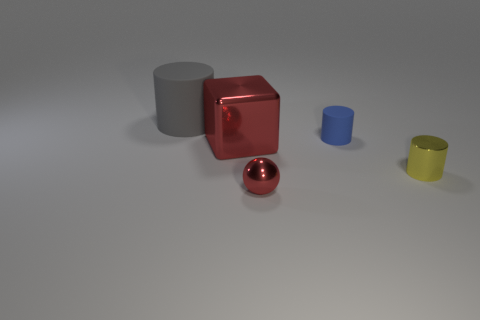What number of big blocks are in front of the cylinder behind the blue cylinder?
Offer a terse response. 1. There is a rubber object in front of the rubber thing that is left of the blue rubber cylinder; what color is it?
Your answer should be very brief. Blue. There is a thing that is both behind the large metal object and to the right of the red metallic block; what is it made of?
Make the answer very short. Rubber. Is there another rubber object of the same shape as the gray thing?
Provide a short and direct response. Yes. There is a large object in front of the blue object; does it have the same shape as the gray rubber object?
Provide a short and direct response. No. What number of objects are to the right of the big metallic thing and behind the metallic ball?
Provide a succinct answer. 2. There is a matte object that is in front of the large cylinder; what shape is it?
Provide a succinct answer. Cylinder. How many red things are made of the same material as the blue thing?
Offer a terse response. 0. There is a tiny red object; is its shape the same as the shiny thing right of the metal sphere?
Your answer should be very brief. No. Are there any yellow metal objects that are in front of the metal thing behind the yellow metal object to the right of the gray thing?
Ensure brevity in your answer.  Yes. 